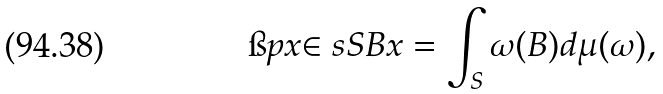Convert formula to latex. <formula><loc_0><loc_0><loc_500><loc_500>\i p { x } { \in s { S } { B } x } = \int _ { S } \omega ( B ) d \mu ( \omega ) ,</formula> 